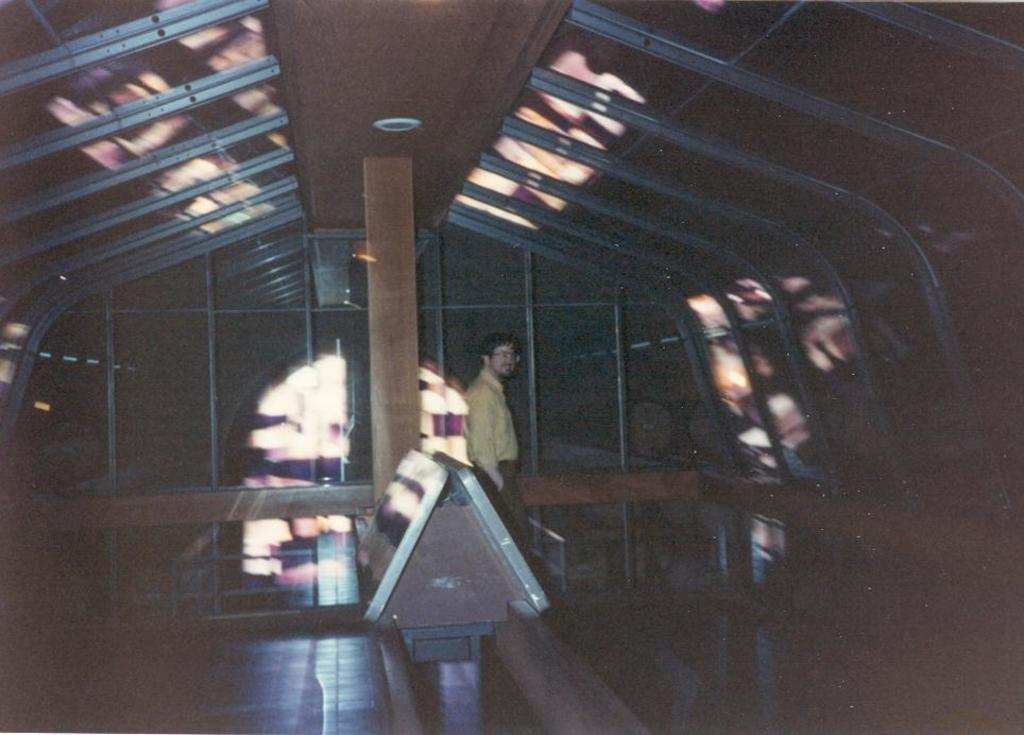What part of a building is shown in the image? The image shows the inner part of a building. Can you describe any activity taking place in the image? There is a person walking in the image. What architectural feature can be seen in the image? There is a pillar visible in the image. What allows natural light to enter the building in the image? There are windows in the image. How many girls are skating in the image? There are no girls or skating activity present in the image. 